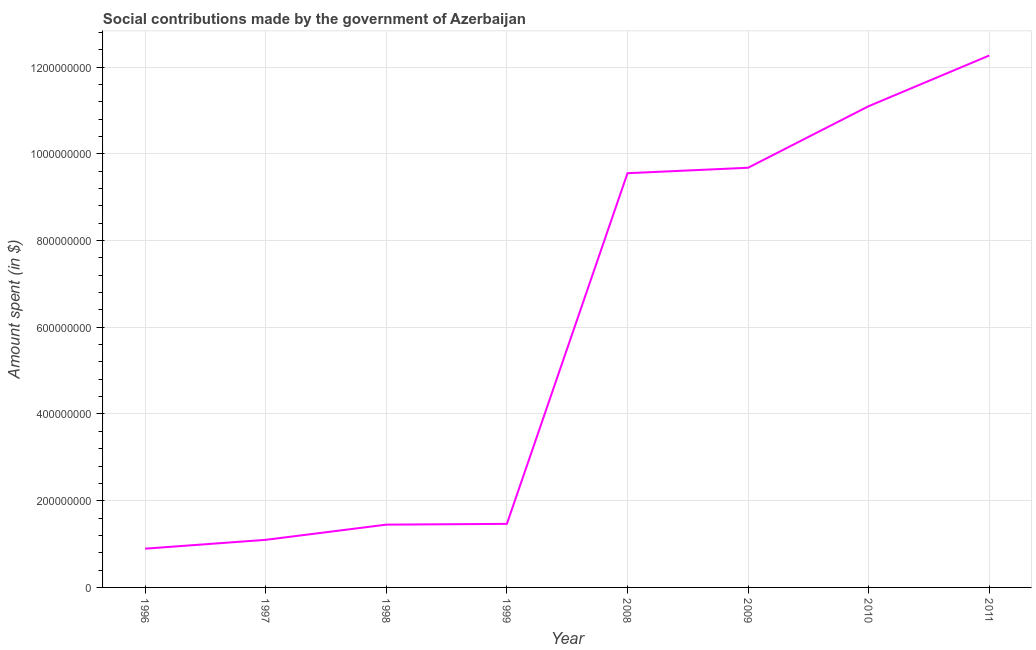What is the amount spent in making social contributions in 1998?
Provide a succinct answer. 1.45e+08. Across all years, what is the maximum amount spent in making social contributions?
Your answer should be very brief. 1.23e+09. Across all years, what is the minimum amount spent in making social contributions?
Offer a terse response. 8.94e+07. What is the sum of the amount spent in making social contributions?
Provide a short and direct response. 4.75e+09. What is the difference between the amount spent in making social contributions in 1998 and 2010?
Provide a short and direct response. -9.65e+08. What is the average amount spent in making social contributions per year?
Offer a terse response. 5.94e+08. What is the median amount spent in making social contributions?
Your response must be concise. 5.51e+08. In how many years, is the amount spent in making social contributions greater than 1040000000 $?
Provide a succinct answer. 2. What is the ratio of the amount spent in making social contributions in 1998 to that in 2011?
Provide a succinct answer. 0.12. What is the difference between the highest and the second highest amount spent in making social contributions?
Provide a succinct answer. 1.17e+08. What is the difference between the highest and the lowest amount spent in making social contributions?
Keep it short and to the point. 1.14e+09. In how many years, is the amount spent in making social contributions greater than the average amount spent in making social contributions taken over all years?
Keep it short and to the point. 4. Does the amount spent in making social contributions monotonically increase over the years?
Give a very brief answer. Yes. How many lines are there?
Ensure brevity in your answer.  1. How many years are there in the graph?
Ensure brevity in your answer.  8. What is the difference between two consecutive major ticks on the Y-axis?
Make the answer very short. 2.00e+08. Does the graph contain any zero values?
Make the answer very short. No. What is the title of the graph?
Give a very brief answer. Social contributions made by the government of Azerbaijan. What is the label or title of the Y-axis?
Your response must be concise. Amount spent (in $). What is the Amount spent (in $) of 1996?
Your answer should be compact. 8.94e+07. What is the Amount spent (in $) of 1997?
Your response must be concise. 1.10e+08. What is the Amount spent (in $) of 1998?
Offer a very short reply. 1.45e+08. What is the Amount spent (in $) of 1999?
Offer a terse response. 1.47e+08. What is the Amount spent (in $) of 2008?
Offer a terse response. 9.55e+08. What is the Amount spent (in $) in 2009?
Your response must be concise. 9.68e+08. What is the Amount spent (in $) in 2010?
Give a very brief answer. 1.11e+09. What is the Amount spent (in $) of 2011?
Keep it short and to the point. 1.23e+09. What is the difference between the Amount spent (in $) in 1996 and 1997?
Keep it short and to the point. -2.04e+07. What is the difference between the Amount spent (in $) in 1996 and 1998?
Give a very brief answer. -5.54e+07. What is the difference between the Amount spent (in $) in 1996 and 1999?
Your answer should be very brief. -5.72e+07. What is the difference between the Amount spent (in $) in 1996 and 2008?
Make the answer very short. -8.66e+08. What is the difference between the Amount spent (in $) in 1996 and 2009?
Offer a very short reply. -8.79e+08. What is the difference between the Amount spent (in $) in 1996 and 2010?
Ensure brevity in your answer.  -1.02e+09. What is the difference between the Amount spent (in $) in 1996 and 2011?
Ensure brevity in your answer.  -1.14e+09. What is the difference between the Amount spent (in $) in 1997 and 1998?
Offer a very short reply. -3.50e+07. What is the difference between the Amount spent (in $) in 1997 and 1999?
Offer a very short reply. -3.68e+07. What is the difference between the Amount spent (in $) in 1997 and 2008?
Offer a very short reply. -8.46e+08. What is the difference between the Amount spent (in $) in 1997 and 2009?
Offer a terse response. -8.58e+08. What is the difference between the Amount spent (in $) in 1997 and 2010?
Ensure brevity in your answer.  -1.00e+09. What is the difference between the Amount spent (in $) in 1997 and 2011?
Give a very brief answer. -1.12e+09. What is the difference between the Amount spent (in $) in 1998 and 1999?
Offer a very short reply. -1.81e+06. What is the difference between the Amount spent (in $) in 1998 and 2008?
Your response must be concise. -8.11e+08. What is the difference between the Amount spent (in $) in 1998 and 2009?
Provide a short and direct response. -8.23e+08. What is the difference between the Amount spent (in $) in 1998 and 2010?
Ensure brevity in your answer.  -9.65e+08. What is the difference between the Amount spent (in $) in 1998 and 2011?
Provide a succinct answer. -1.08e+09. What is the difference between the Amount spent (in $) in 1999 and 2008?
Your answer should be very brief. -8.09e+08. What is the difference between the Amount spent (in $) in 1999 and 2009?
Offer a very short reply. -8.21e+08. What is the difference between the Amount spent (in $) in 1999 and 2010?
Make the answer very short. -9.63e+08. What is the difference between the Amount spent (in $) in 1999 and 2011?
Offer a terse response. -1.08e+09. What is the difference between the Amount spent (in $) in 2008 and 2009?
Provide a succinct answer. -1.26e+07. What is the difference between the Amount spent (in $) in 2008 and 2010?
Offer a very short reply. -1.55e+08. What is the difference between the Amount spent (in $) in 2008 and 2011?
Offer a very short reply. -2.72e+08. What is the difference between the Amount spent (in $) in 2009 and 2010?
Your answer should be very brief. -1.42e+08. What is the difference between the Amount spent (in $) in 2009 and 2011?
Provide a short and direct response. -2.59e+08. What is the difference between the Amount spent (in $) in 2010 and 2011?
Provide a short and direct response. -1.17e+08. What is the ratio of the Amount spent (in $) in 1996 to that in 1997?
Offer a very short reply. 0.81. What is the ratio of the Amount spent (in $) in 1996 to that in 1998?
Keep it short and to the point. 0.62. What is the ratio of the Amount spent (in $) in 1996 to that in 1999?
Give a very brief answer. 0.61. What is the ratio of the Amount spent (in $) in 1996 to that in 2008?
Your answer should be very brief. 0.09. What is the ratio of the Amount spent (in $) in 1996 to that in 2009?
Provide a short and direct response. 0.09. What is the ratio of the Amount spent (in $) in 1996 to that in 2010?
Offer a very short reply. 0.08. What is the ratio of the Amount spent (in $) in 1996 to that in 2011?
Ensure brevity in your answer.  0.07. What is the ratio of the Amount spent (in $) in 1997 to that in 1998?
Offer a very short reply. 0.76. What is the ratio of the Amount spent (in $) in 1997 to that in 1999?
Your response must be concise. 0.75. What is the ratio of the Amount spent (in $) in 1997 to that in 2008?
Offer a very short reply. 0.12. What is the ratio of the Amount spent (in $) in 1997 to that in 2009?
Provide a short and direct response. 0.11. What is the ratio of the Amount spent (in $) in 1997 to that in 2010?
Offer a terse response. 0.1. What is the ratio of the Amount spent (in $) in 1997 to that in 2011?
Make the answer very short. 0.09. What is the ratio of the Amount spent (in $) in 1998 to that in 2008?
Your answer should be very brief. 0.15. What is the ratio of the Amount spent (in $) in 1998 to that in 2009?
Keep it short and to the point. 0.15. What is the ratio of the Amount spent (in $) in 1998 to that in 2010?
Offer a very short reply. 0.13. What is the ratio of the Amount spent (in $) in 1998 to that in 2011?
Provide a short and direct response. 0.12. What is the ratio of the Amount spent (in $) in 1999 to that in 2008?
Offer a very short reply. 0.15. What is the ratio of the Amount spent (in $) in 1999 to that in 2009?
Provide a succinct answer. 0.15. What is the ratio of the Amount spent (in $) in 1999 to that in 2010?
Your answer should be very brief. 0.13. What is the ratio of the Amount spent (in $) in 1999 to that in 2011?
Offer a terse response. 0.12. What is the ratio of the Amount spent (in $) in 2008 to that in 2009?
Give a very brief answer. 0.99. What is the ratio of the Amount spent (in $) in 2008 to that in 2010?
Provide a short and direct response. 0.86. What is the ratio of the Amount spent (in $) in 2008 to that in 2011?
Offer a terse response. 0.78. What is the ratio of the Amount spent (in $) in 2009 to that in 2010?
Ensure brevity in your answer.  0.87. What is the ratio of the Amount spent (in $) in 2009 to that in 2011?
Make the answer very short. 0.79. What is the ratio of the Amount spent (in $) in 2010 to that in 2011?
Keep it short and to the point. 0.91. 